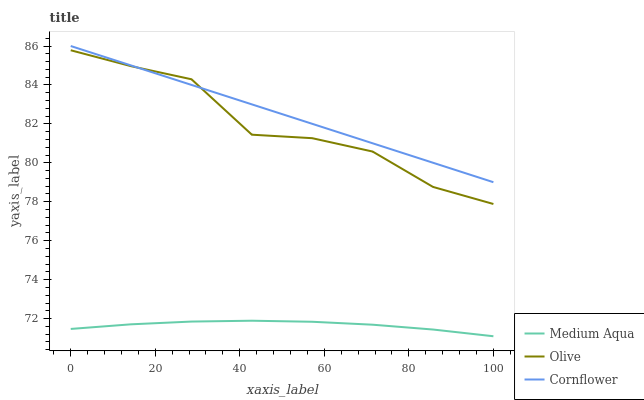Does Medium Aqua have the minimum area under the curve?
Answer yes or no. Yes. Does Cornflower have the maximum area under the curve?
Answer yes or no. Yes. Does Cornflower have the minimum area under the curve?
Answer yes or no. No. Does Medium Aqua have the maximum area under the curve?
Answer yes or no. No. Is Cornflower the smoothest?
Answer yes or no. Yes. Is Olive the roughest?
Answer yes or no. Yes. Is Medium Aqua the smoothest?
Answer yes or no. No. Is Medium Aqua the roughest?
Answer yes or no. No. Does Medium Aqua have the lowest value?
Answer yes or no. Yes. Does Cornflower have the lowest value?
Answer yes or no. No. Does Cornflower have the highest value?
Answer yes or no. Yes. Does Medium Aqua have the highest value?
Answer yes or no. No. Is Medium Aqua less than Cornflower?
Answer yes or no. Yes. Is Cornflower greater than Medium Aqua?
Answer yes or no. Yes. Does Olive intersect Cornflower?
Answer yes or no. Yes. Is Olive less than Cornflower?
Answer yes or no. No. Is Olive greater than Cornflower?
Answer yes or no. No. Does Medium Aqua intersect Cornflower?
Answer yes or no. No. 